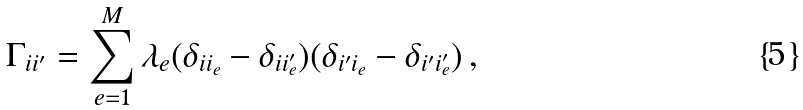<formula> <loc_0><loc_0><loc_500><loc_500>\Gamma _ { i i ^ { \prime } } = \sum _ { e = 1 } ^ { M } \lambda _ { e } ( \delta _ { i i _ { e } } - \delta _ { i i _ { e } ^ { \prime } } ) ( \delta _ { i ^ { \prime } i _ { e } } - \delta _ { i ^ { \prime } i _ { e } ^ { \prime } } ) \, ,</formula> 